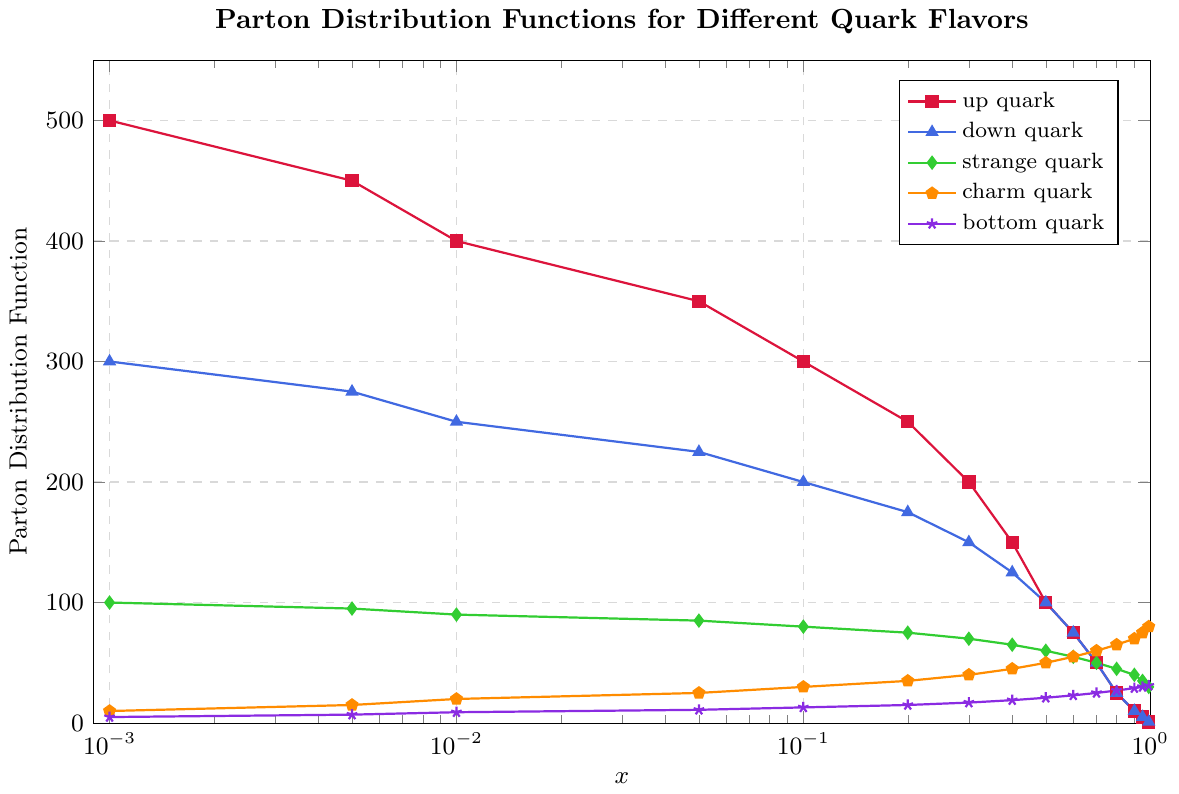What's the value of the Parton distribution function for the up quark when the momentum fraction is 0.05? At the momentum fraction of 0.05, the up quark has a Parton distribution function value of 350 as indicated on the plot.
Answer: 350 How does the Parton distribution function for the strange quark compare to that of the down quark at a momentum fraction of 0.1? At a momentum fraction of 0.1, the Parton distribution function for the down quark is 200, while for the strange quark it is 80.
Answer: The down quark's function is greater than the strange quark's by 120 Which quark flavor has the steepest decline in Parton distribution function values as the momentum fraction increases from 0.001 to 0.01? The up quark declines from 500 to 400, a drop of 100 units. Down quark declines from 300 to 250, a drop of 50 units. Strange quark declines from 100 to 90, a drop of 10. Charm quark increases from 10 to 20, an increase of 10. Bottom quark increases from 5 to 9, an increase of 4. Thus, the up quark has the steepest decline.
Answer: Up quark What is the sum of the Parton distribution function values for the charm and bottom quark at a momentum fraction of 0.4? At 0.4, the charm quark has a value of 45 and the bottom quark has 19. Adding these gives 45 + 19 = 64.
Answer: 64 For which quark flavor does the Parton distribution function peak at the lowest momentum fraction and what is that fraction? Up quark peaks at 0.001 with a value of 500. All other quark flavors also have their highest values at the lowest momentum fraction of 0.001.
Answer: Up quark, 0.001 At a momentum fraction of 0.8, which quark flavor has a higher Parton distribution function value: charm or bottom? At 0.8, the charm quark has a value of 65, while the bottom quark has a value of 27.
Answer: Charm quark What is the difference between the Parton distribution function values of the up quark and down quark at a momentum fraction of 0.3? At 0.3, the up quark has a value of 200 and the down quark has 150. The difference is 200 - 150 = 50.
Answer: 50 Which quark flavor's Parton distribution function values decrease monotonically as the momentum fraction increases? By observing the plot, the up quark steadily decreases from 500 to 1 as momentum fraction increases from 0.001 to 0.99 without increasing at any step.
Answer: Up quark At a momentum fraction of 0.95, does the strange quark's Parton distribution function have a higher or lower value compared to the charm quark? At 0.95, the strange quark's value is 35 while the charm quark's value is 75.
Answer: Lower What is the average of the Parton distribution function values for the down quark across all momentum fractions? Summing the down quark values: 300 + 275 + 250 + 225 + 200 + 175 + 150 + 125 + 100 + 75 + 50 + 25 + 10 + 5 + 1 = 1966. The average is 1966 / 15 ≈ 131.1.
Answer: Approximately 131.1 